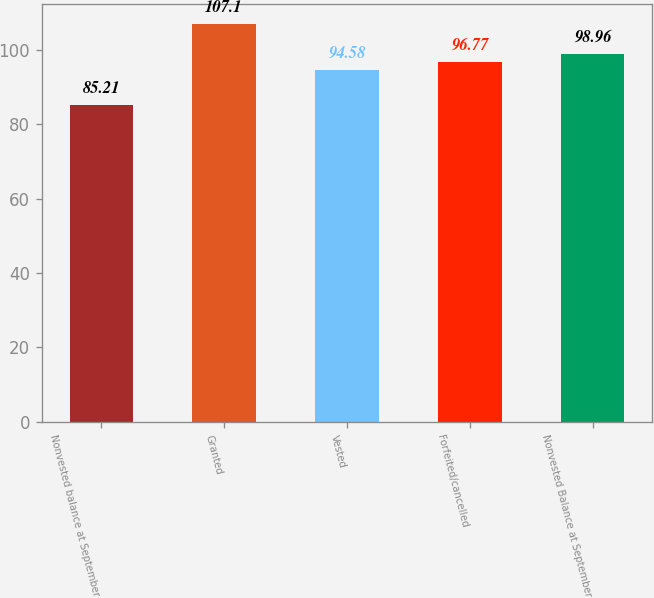Convert chart. <chart><loc_0><loc_0><loc_500><loc_500><bar_chart><fcel>Nonvested balance at September<fcel>Granted<fcel>Vested<fcel>Forfeited/cancelled<fcel>Nonvested Balance at September<nl><fcel>85.21<fcel>107.1<fcel>94.58<fcel>96.77<fcel>98.96<nl></chart> 